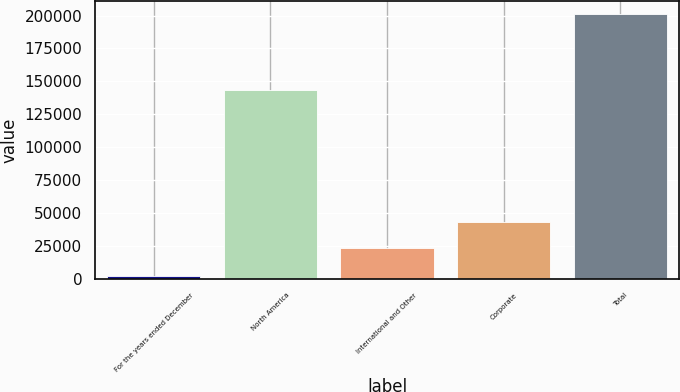Convert chart. <chart><loc_0><loc_0><loc_500><loc_500><bar_chart><fcel>For the years ended December<fcel>North America<fcel>International and Other<fcel>Corporate<fcel>Total<nl><fcel>2013<fcel>143640<fcel>23461<fcel>43363<fcel>201033<nl></chart> 